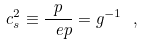<formula> <loc_0><loc_0><loc_500><loc_500>c _ { s } ^ { 2 } \equiv \frac { p } { \ e p } = { g } ^ { - 1 } \ ,</formula> 